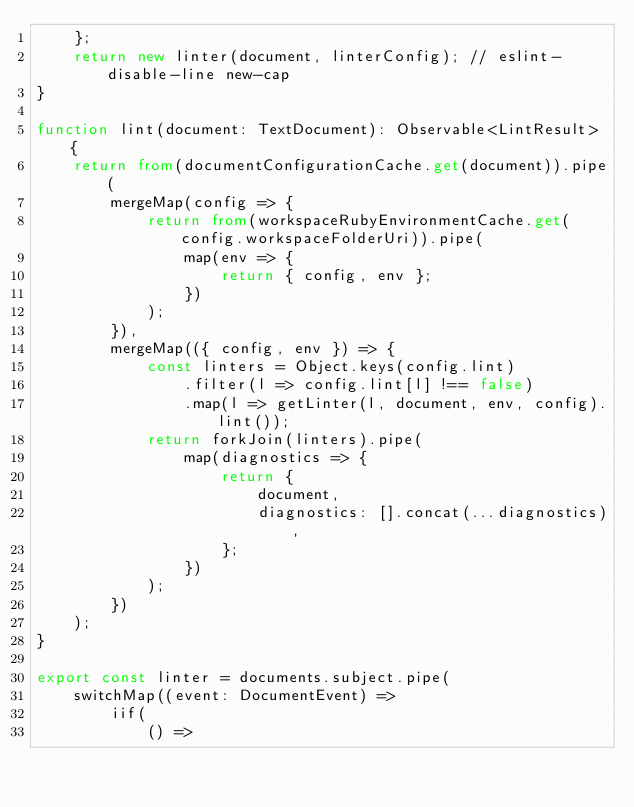Convert code to text. <code><loc_0><loc_0><loc_500><loc_500><_TypeScript_>	};
	return new linter(document, linterConfig); // eslint-disable-line new-cap
}

function lint(document: TextDocument): Observable<LintResult> {
	return from(documentConfigurationCache.get(document)).pipe(
		mergeMap(config => {
			return from(workspaceRubyEnvironmentCache.get(config.workspaceFolderUri)).pipe(
				map(env => {
					return { config, env };
				})
			);
		}),
		mergeMap(({ config, env }) => {
			const linters = Object.keys(config.lint)
				.filter(l => config.lint[l] !== false)
				.map(l => getLinter(l, document, env, config).lint());
			return forkJoin(linters).pipe(
				map(diagnostics => {
					return {
						document,
						diagnostics: [].concat(...diagnostics),
					};
				})
			);
		})
	);
}

export const linter = documents.subject.pipe(
	switchMap((event: DocumentEvent) =>
		iif(
			() =></code> 